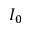<formula> <loc_0><loc_0><loc_500><loc_500>I _ { 0 }</formula> 